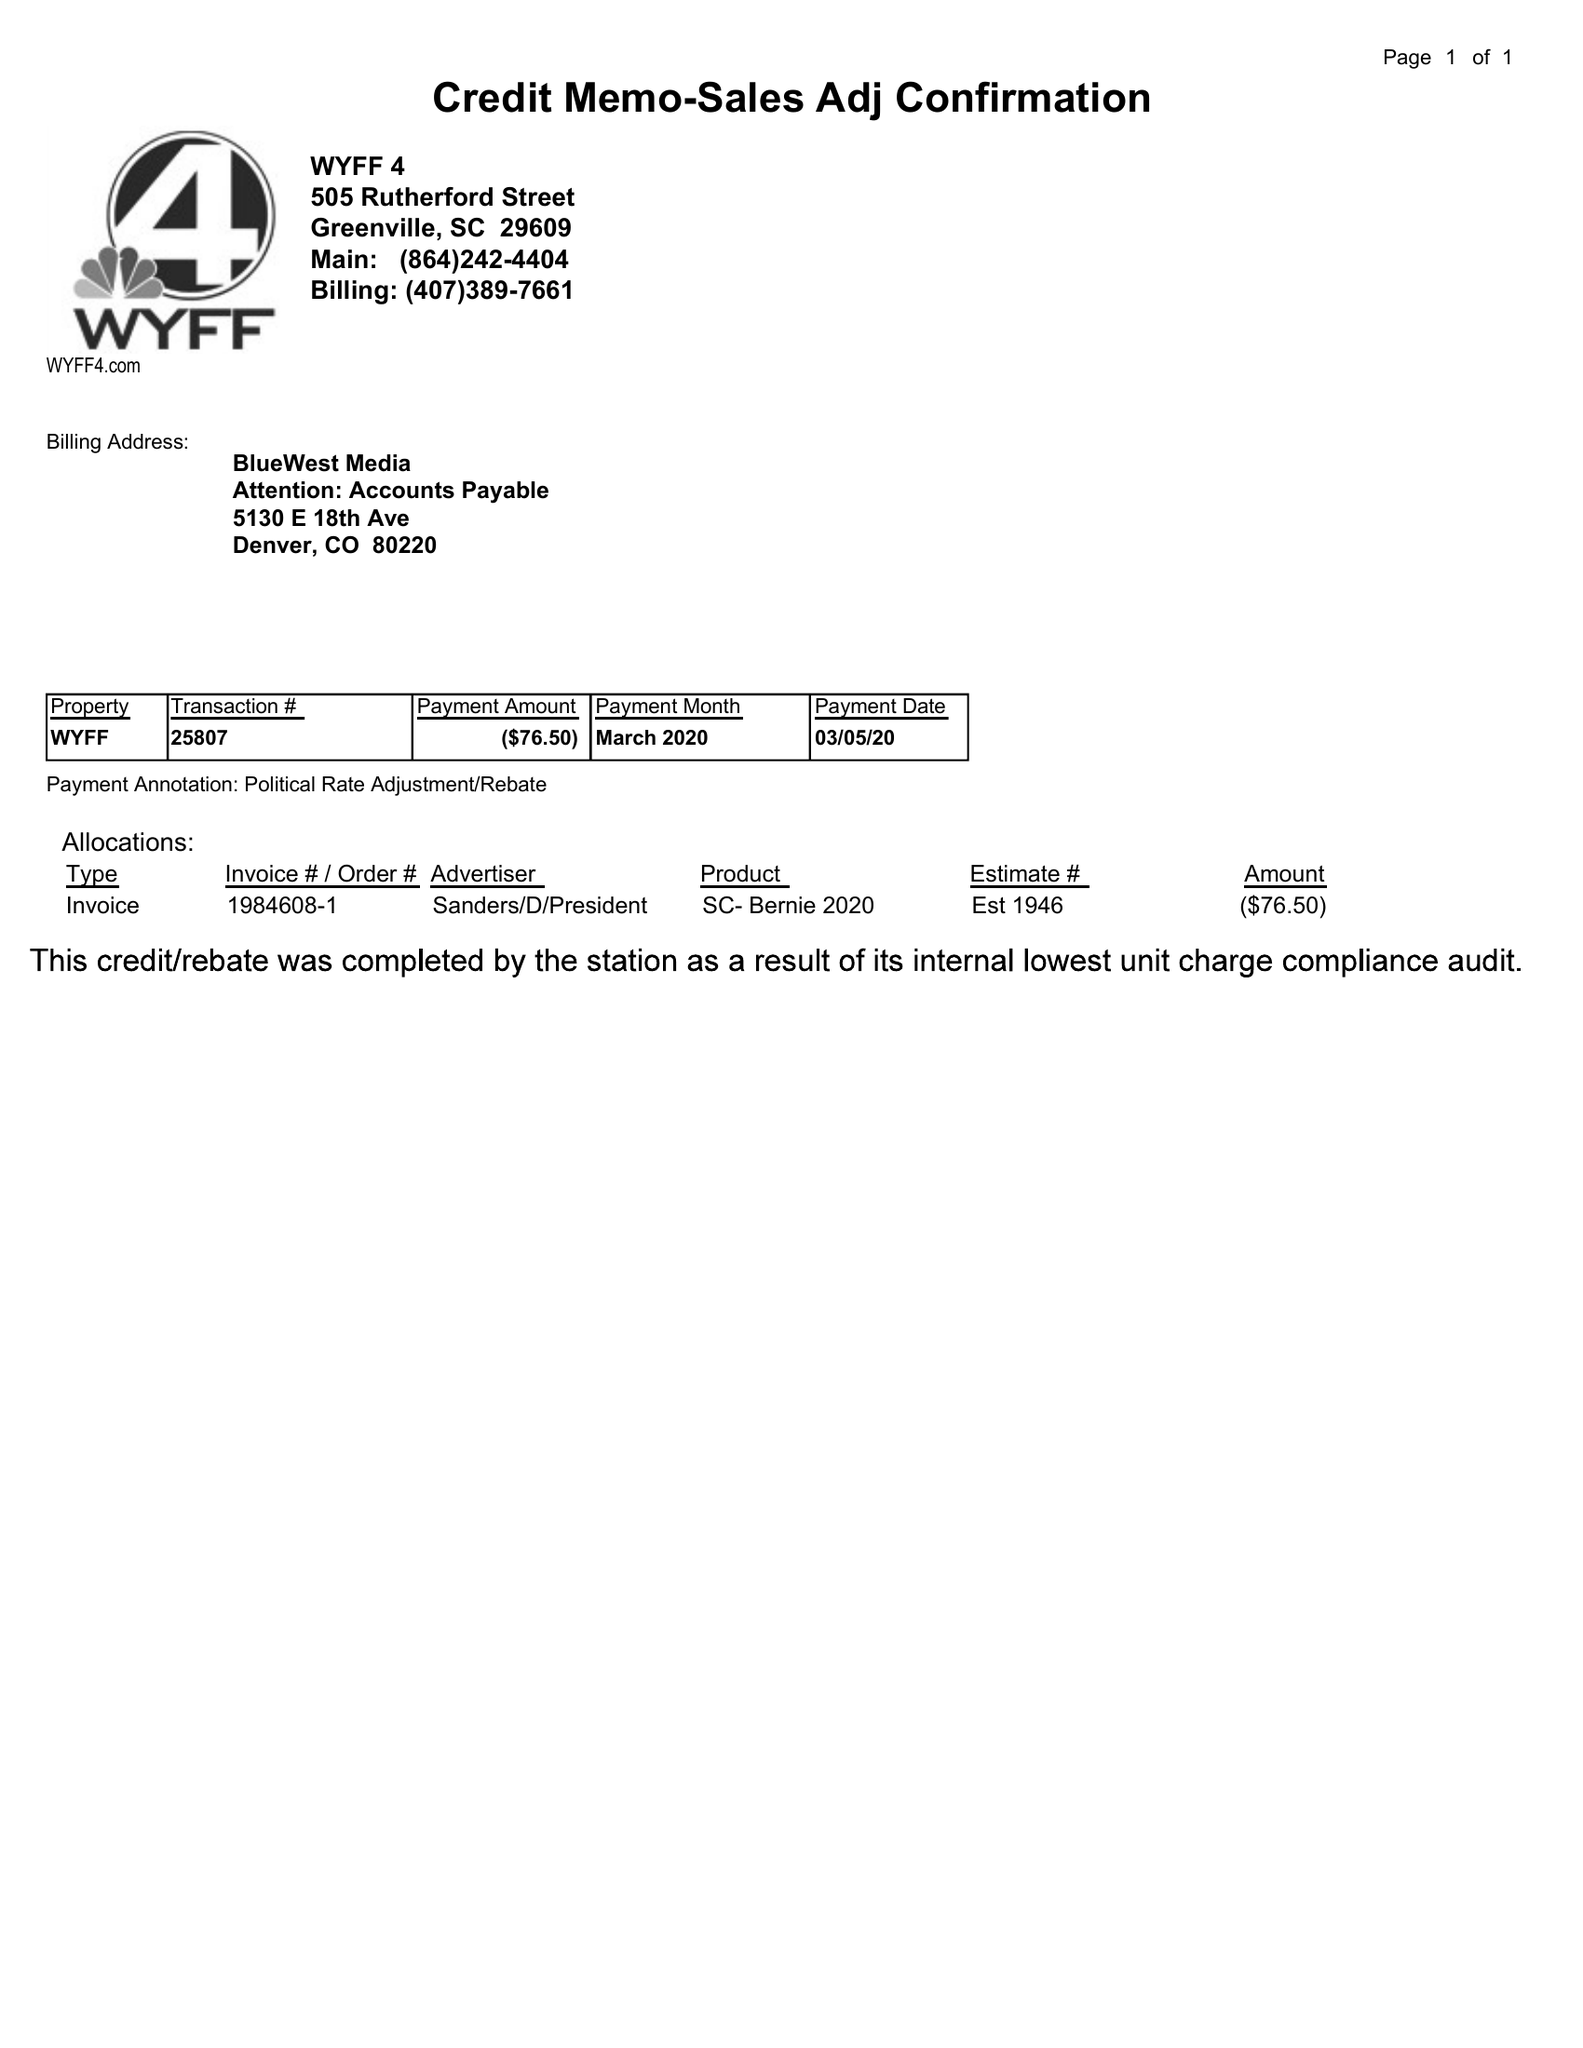What is the value for the gross_amount?
Answer the question using a single word or phrase. -76.50 